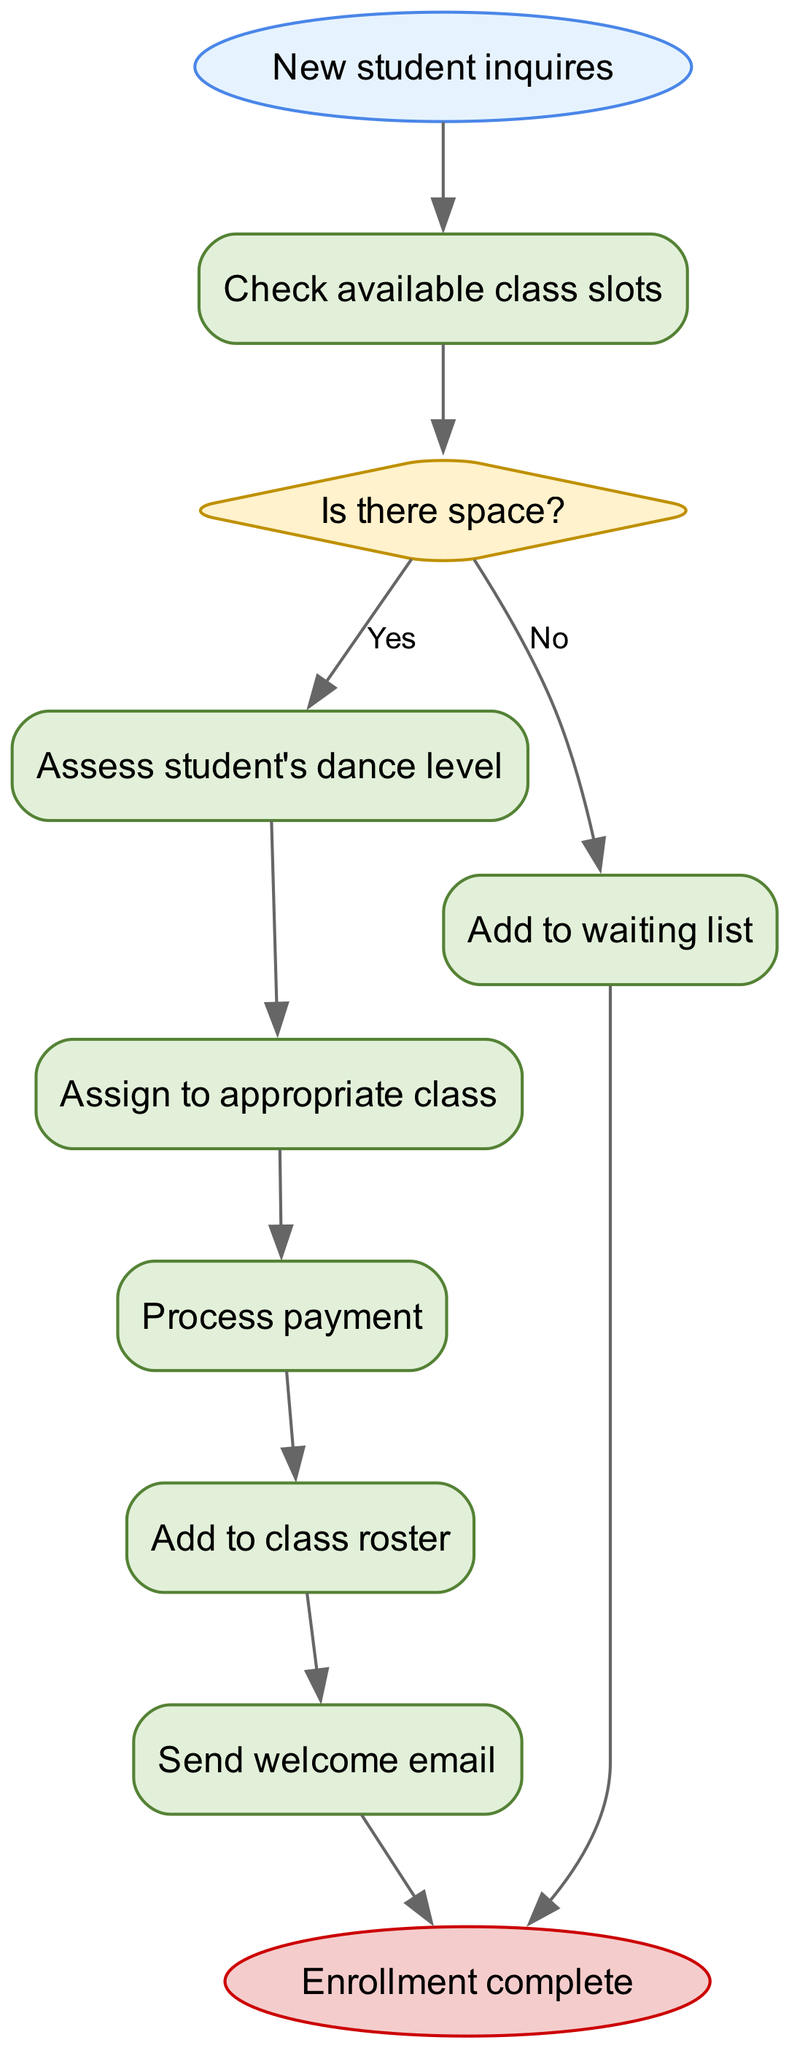What is the starting point of the flowchart? The flowchart begins with the node labeled "New student inquires," which indicates the initiation of the student enrollment process.
Answer: New student inquires How many process nodes are in the diagram? By counting the nodes categorized as 'process' in the diagram, we identify six of them: "Check available class slots," "Assess student's dance level," "Assign to appropriate class," "Process payment," "Add to class roster," and "Send welcome email."
Answer: 6 What decision does the flowchart present? The flowchart presents one decision point labeled "Is there space?" This decision evaluates whether there are available slots in the class for a new student.
Answer: Is there space? What happens if there is no space in a class? If there is no space in the class, the flowchart indicates that the new student will be added to the waiting list, implying their enrollment cannot proceed immediately.
Answer: Add to waiting list List the final step in the enrollment process. The final step, after all prior processes are completed (or if the student is added to the waiting list), is labeled "Enrollment complete," signifying that the enrollment workflow has concluded.
Answer: Enrollment complete What is the purpose of the "Send welcome email" process? The "Send welcome email" process, occurring after the student is added to the class roster, serves the purpose of welcoming the new student, confirming their enrollment and providing necessary information for their upcoming dance classes.
Answer: Welcoming the new student How can a new student be assigned to a class? A new student can be assigned to a class after their dance level is assessed. This step connects their skill level with an appropriate class, ensuring a suitable match for their learning experience.
Answer: Assess student's dance level Which node follows the "Process payment" step? Directly following the "Process payment" step, the flowchart illustrates the next step as "Add to class roster," indicating that once payment is completed, the student's information will be added to the class roster.
Answer: Add to class roster 